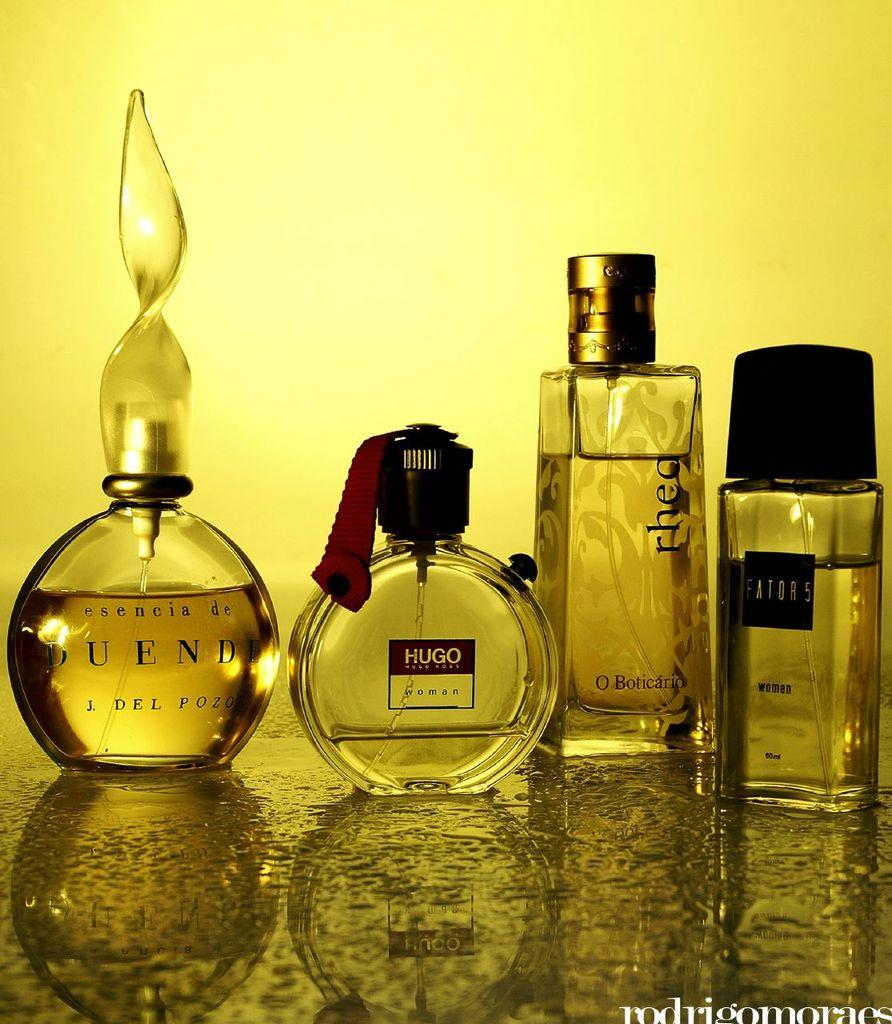<image>
Summarize the visual content of the image. Different bottles of perfume and cologne one of which is by Hugo 